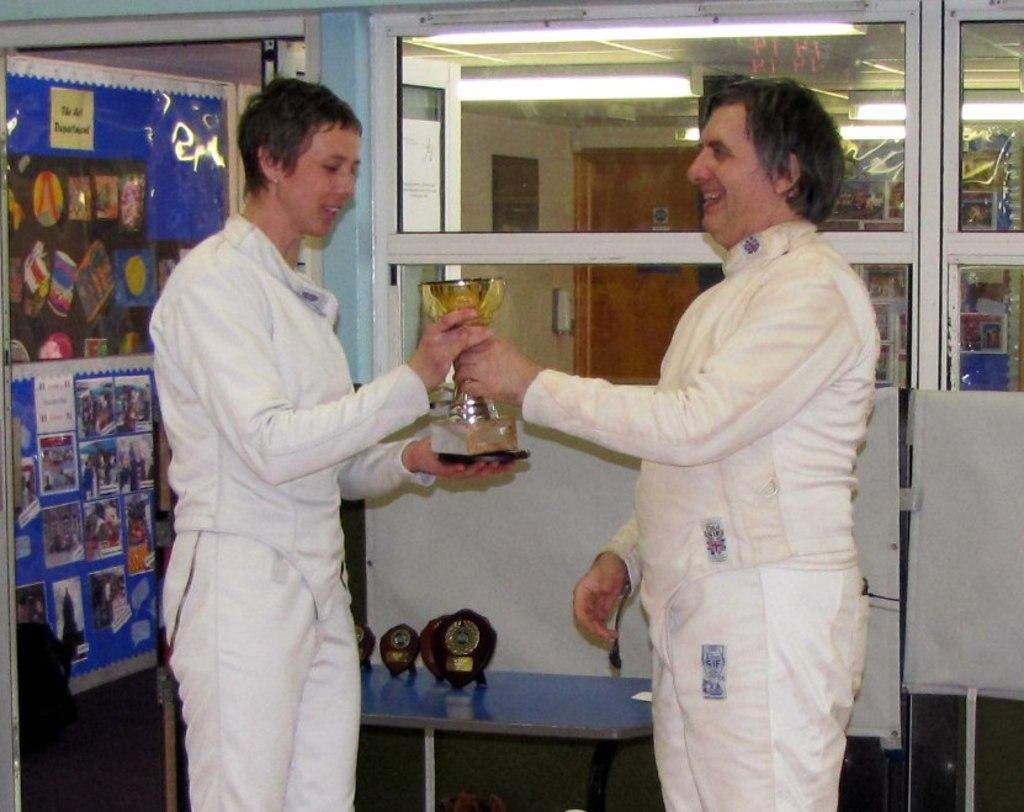How many people are in the image? There are two persons in the image. What are the persons wearing? Both persons are wearing white dresses. What are the persons holding in the image? The persons are holding a trophy. What can be seen in the background of the image? There are shields and photographs in the background of the image. What is visible at the bottom of the image? There is a floor visible at the bottom of the image. What type of line can be seen running through the downtown area in the image? There is no downtown area or line visible in the image. What is the pump used for in the image? There is no pump present in the image. 